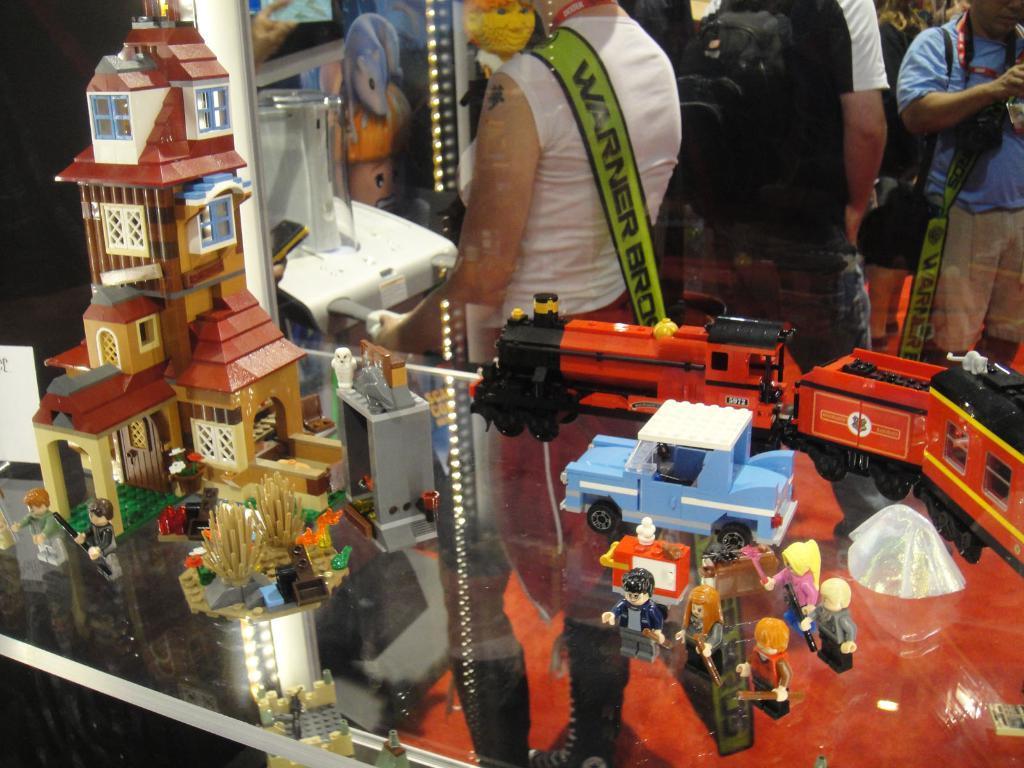In one or two sentences, can you explain what this image depicts? In this image there are a few toys are arranged on the glass table, through the glass we can see there are a few people standing, few are holding some objects and few are wearing bags on their shoulder. 